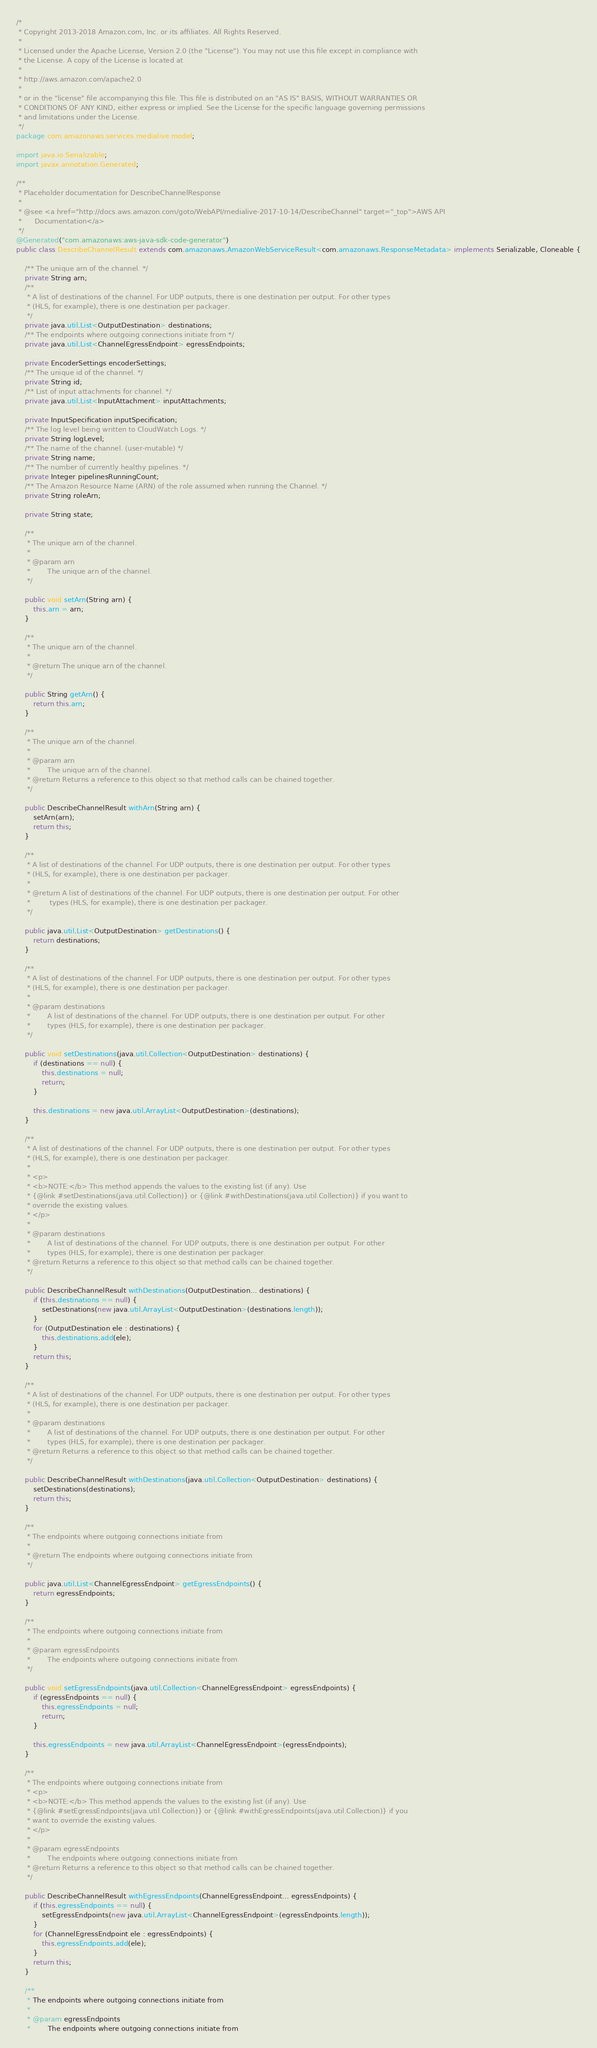Convert code to text. <code><loc_0><loc_0><loc_500><loc_500><_Java_>/*
 * Copyright 2013-2018 Amazon.com, Inc. or its affiliates. All Rights Reserved.
 * 
 * Licensed under the Apache License, Version 2.0 (the "License"). You may not use this file except in compliance with
 * the License. A copy of the License is located at
 * 
 * http://aws.amazon.com/apache2.0
 * 
 * or in the "license" file accompanying this file. This file is distributed on an "AS IS" BASIS, WITHOUT WARRANTIES OR
 * CONDITIONS OF ANY KIND, either express or implied. See the License for the specific language governing permissions
 * and limitations under the License.
 */
package com.amazonaws.services.medialive.model;

import java.io.Serializable;
import javax.annotation.Generated;

/**
 * Placeholder documentation for DescribeChannelResponse
 * 
 * @see <a href="http://docs.aws.amazon.com/goto/WebAPI/medialive-2017-10-14/DescribeChannel" target="_top">AWS API
 *      Documentation</a>
 */
@Generated("com.amazonaws:aws-java-sdk-code-generator")
public class DescribeChannelResult extends com.amazonaws.AmazonWebServiceResult<com.amazonaws.ResponseMetadata> implements Serializable, Cloneable {

    /** The unique arn of the channel. */
    private String arn;
    /**
     * A list of destinations of the channel. For UDP outputs, there is one destination per output. For other types
     * (HLS, for example), there is one destination per packager.
     */
    private java.util.List<OutputDestination> destinations;
    /** The endpoints where outgoing connections initiate from */
    private java.util.List<ChannelEgressEndpoint> egressEndpoints;

    private EncoderSettings encoderSettings;
    /** The unique id of the channel. */
    private String id;
    /** List of input attachments for channel. */
    private java.util.List<InputAttachment> inputAttachments;

    private InputSpecification inputSpecification;
    /** The log level being written to CloudWatch Logs. */
    private String logLevel;
    /** The name of the channel. (user-mutable) */
    private String name;
    /** The number of currently healthy pipelines. */
    private Integer pipelinesRunningCount;
    /** The Amazon Resource Name (ARN) of the role assumed when running the Channel. */
    private String roleArn;

    private String state;

    /**
     * The unique arn of the channel.
     * 
     * @param arn
     *        The unique arn of the channel.
     */

    public void setArn(String arn) {
        this.arn = arn;
    }

    /**
     * The unique arn of the channel.
     * 
     * @return The unique arn of the channel.
     */

    public String getArn() {
        return this.arn;
    }

    /**
     * The unique arn of the channel.
     * 
     * @param arn
     *        The unique arn of the channel.
     * @return Returns a reference to this object so that method calls can be chained together.
     */

    public DescribeChannelResult withArn(String arn) {
        setArn(arn);
        return this;
    }

    /**
     * A list of destinations of the channel. For UDP outputs, there is one destination per output. For other types
     * (HLS, for example), there is one destination per packager.
     * 
     * @return A list of destinations of the channel. For UDP outputs, there is one destination per output. For other
     *         types (HLS, for example), there is one destination per packager.
     */

    public java.util.List<OutputDestination> getDestinations() {
        return destinations;
    }

    /**
     * A list of destinations of the channel. For UDP outputs, there is one destination per output. For other types
     * (HLS, for example), there is one destination per packager.
     * 
     * @param destinations
     *        A list of destinations of the channel. For UDP outputs, there is one destination per output. For other
     *        types (HLS, for example), there is one destination per packager.
     */

    public void setDestinations(java.util.Collection<OutputDestination> destinations) {
        if (destinations == null) {
            this.destinations = null;
            return;
        }

        this.destinations = new java.util.ArrayList<OutputDestination>(destinations);
    }

    /**
     * A list of destinations of the channel. For UDP outputs, there is one destination per output. For other types
     * (HLS, for example), there is one destination per packager.
     * 
     * <p>
     * <b>NOTE:</b> This method appends the values to the existing list (if any). Use
     * {@link #setDestinations(java.util.Collection)} or {@link #withDestinations(java.util.Collection)} if you want to
     * override the existing values.
     * </p>
     * 
     * @param destinations
     *        A list of destinations of the channel. For UDP outputs, there is one destination per output. For other
     *        types (HLS, for example), there is one destination per packager.
     * @return Returns a reference to this object so that method calls can be chained together.
     */

    public DescribeChannelResult withDestinations(OutputDestination... destinations) {
        if (this.destinations == null) {
            setDestinations(new java.util.ArrayList<OutputDestination>(destinations.length));
        }
        for (OutputDestination ele : destinations) {
            this.destinations.add(ele);
        }
        return this;
    }

    /**
     * A list of destinations of the channel. For UDP outputs, there is one destination per output. For other types
     * (HLS, for example), there is one destination per packager.
     * 
     * @param destinations
     *        A list of destinations of the channel. For UDP outputs, there is one destination per output. For other
     *        types (HLS, for example), there is one destination per packager.
     * @return Returns a reference to this object so that method calls can be chained together.
     */

    public DescribeChannelResult withDestinations(java.util.Collection<OutputDestination> destinations) {
        setDestinations(destinations);
        return this;
    }

    /**
     * The endpoints where outgoing connections initiate from
     * 
     * @return The endpoints where outgoing connections initiate from
     */

    public java.util.List<ChannelEgressEndpoint> getEgressEndpoints() {
        return egressEndpoints;
    }

    /**
     * The endpoints where outgoing connections initiate from
     * 
     * @param egressEndpoints
     *        The endpoints where outgoing connections initiate from
     */

    public void setEgressEndpoints(java.util.Collection<ChannelEgressEndpoint> egressEndpoints) {
        if (egressEndpoints == null) {
            this.egressEndpoints = null;
            return;
        }

        this.egressEndpoints = new java.util.ArrayList<ChannelEgressEndpoint>(egressEndpoints);
    }

    /**
     * The endpoints where outgoing connections initiate from
     * <p>
     * <b>NOTE:</b> This method appends the values to the existing list (if any). Use
     * {@link #setEgressEndpoints(java.util.Collection)} or {@link #withEgressEndpoints(java.util.Collection)} if you
     * want to override the existing values.
     * </p>
     * 
     * @param egressEndpoints
     *        The endpoints where outgoing connections initiate from
     * @return Returns a reference to this object so that method calls can be chained together.
     */

    public DescribeChannelResult withEgressEndpoints(ChannelEgressEndpoint... egressEndpoints) {
        if (this.egressEndpoints == null) {
            setEgressEndpoints(new java.util.ArrayList<ChannelEgressEndpoint>(egressEndpoints.length));
        }
        for (ChannelEgressEndpoint ele : egressEndpoints) {
            this.egressEndpoints.add(ele);
        }
        return this;
    }

    /**
     * The endpoints where outgoing connections initiate from
     * 
     * @param egressEndpoints
     *        The endpoints where outgoing connections initiate from</code> 